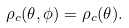Convert formula to latex. <formula><loc_0><loc_0><loc_500><loc_500>\rho _ { c } ( \theta , \phi ) = \rho _ { c } ( \theta ) .</formula> 